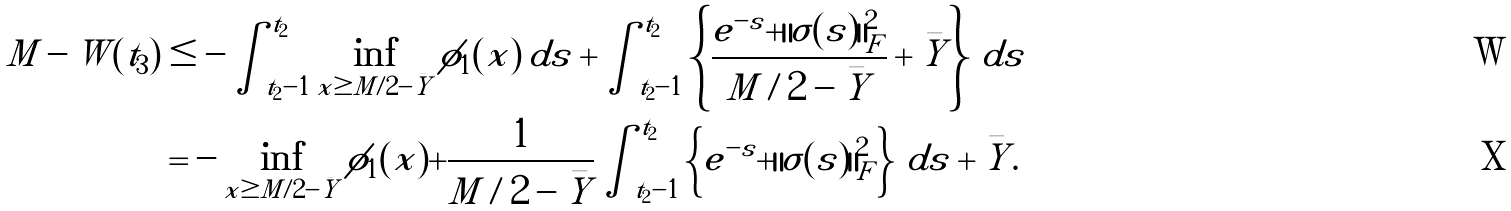Convert formula to latex. <formula><loc_0><loc_0><loc_500><loc_500>M - W ( t _ { 3 } ) & \leq - \int _ { t _ { 2 } - 1 } ^ { t _ { 2 } } \inf _ { x \geq M / 2 - \bar { Y } } \phi _ { 1 } ( x ) \, d s + \int _ { t _ { 2 } - 1 } ^ { t _ { 2 } } \left \{ \frac { e ^ { - s } + \| \sigma ( s ) \| ^ { 2 } _ { F } } { M / 2 - \bar { Y } } + \bar { Y } \right \} \, d s \\ & = - \inf _ { x \geq M / 2 - \bar { Y } } \phi _ { 1 } ( x ) + \frac { 1 } { M / 2 - \bar { Y } } \int _ { t _ { 2 } - 1 } ^ { t _ { 2 } } \left \{ e ^ { - s } + \| \sigma ( s ) \| ^ { 2 } _ { F } \right \} \, d s + \bar { Y } .</formula> 